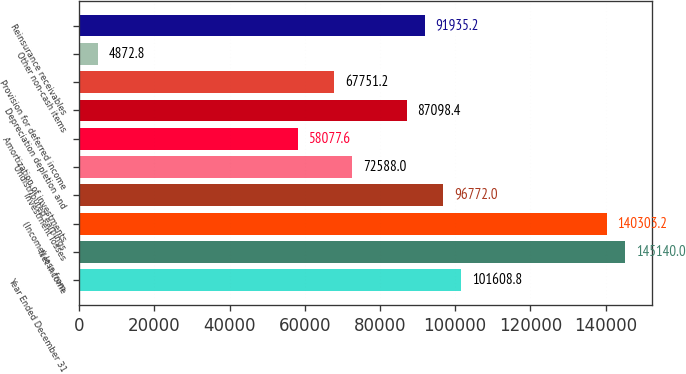Convert chart to OTSL. <chart><loc_0><loc_0><loc_500><loc_500><bar_chart><fcel>Year Ended December 31<fcel>Net income<fcel>(Income) loss from<fcel>Investment losses<fcel>Undistributed earnings<fcel>Amortization of investments<fcel>Depreciation depletion and<fcel>Provision for deferred income<fcel>Other non-cash items<fcel>Reinsurance receivables<nl><fcel>101609<fcel>145140<fcel>140303<fcel>96772<fcel>72588<fcel>58077.6<fcel>87098.4<fcel>67751.2<fcel>4872.8<fcel>91935.2<nl></chart> 